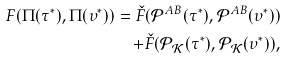<formula> <loc_0><loc_0><loc_500><loc_500>F ( \Pi ( \tau ^ { * } ) , \Pi ( \upsilon ^ { * } ) ) = \check { F } ( \mathcal { P } ^ { A B } ( \tau ^ { * } ) , \mathcal { P } ^ { A B } ( \upsilon ^ { * } ) ) \\ + \check { F } ( \mathcal { P } _ { \mathcal { K } } ( \tau ^ { * } ) , \mathcal { P } _ { \mathcal { K } } ( \upsilon ^ { * } ) ) ,</formula> 